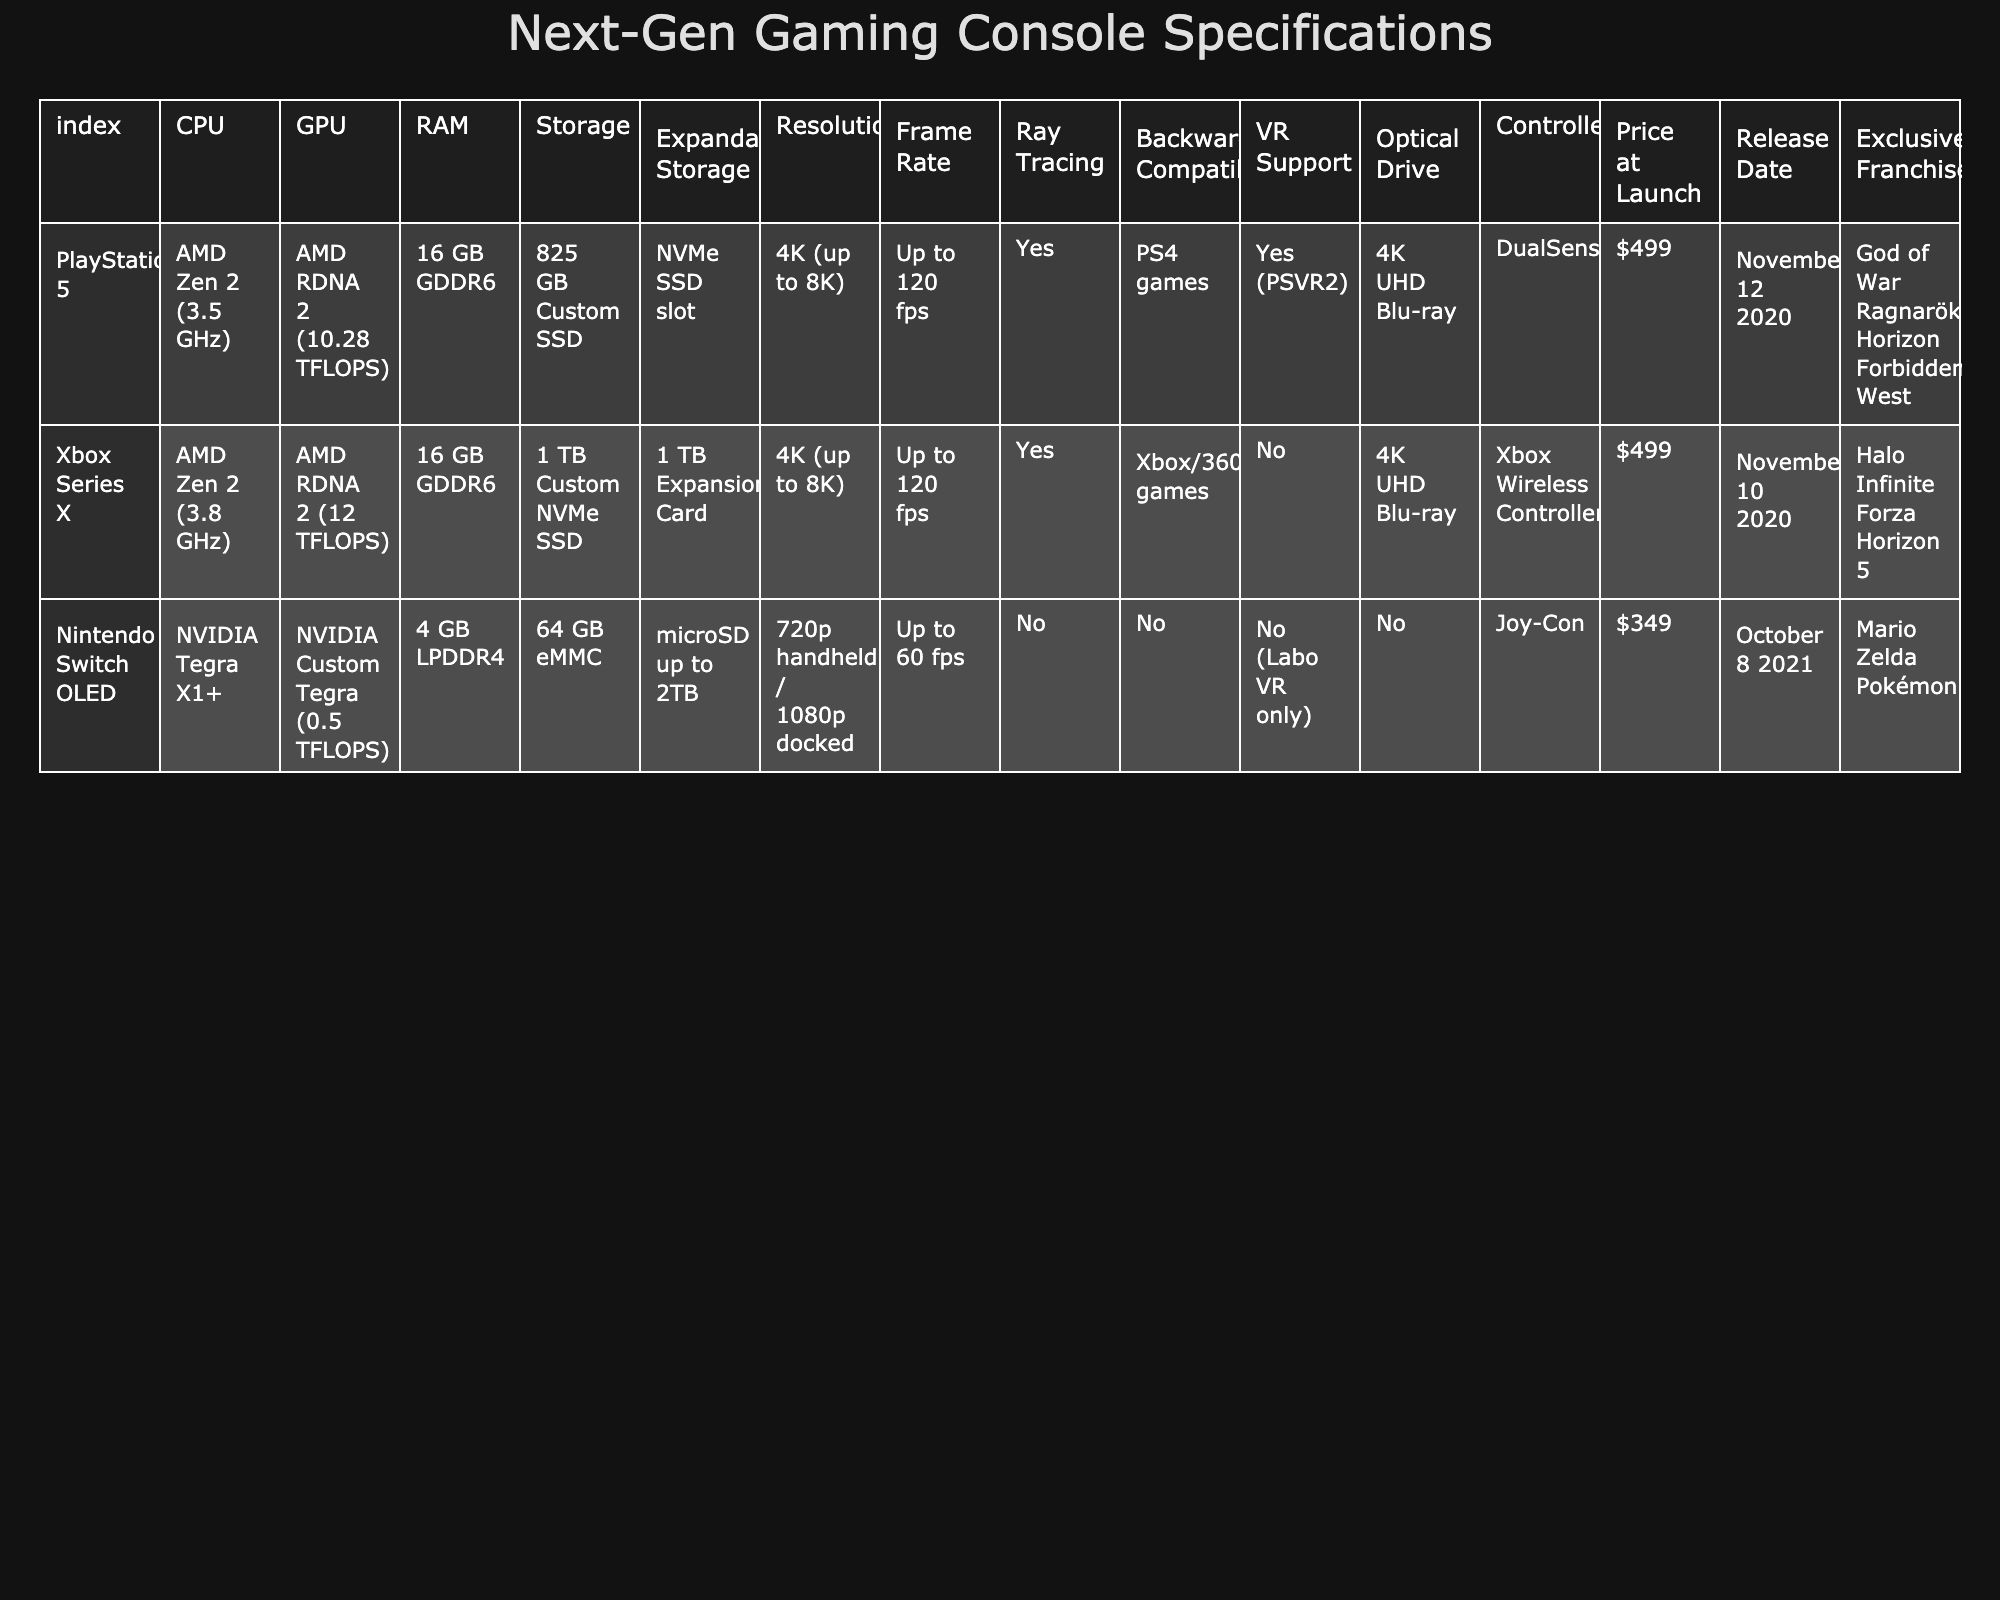What is the CPU model of the Xbox Series X? The Xbox Series X is listed under the "CPU" row of the table. Its CPU is specified as "AMD Zen 2 (3.8 GHz)."
Answer: AMD Zen 2 (3.8 GHz) Which console has the lowest RAM? By looking at the "RAM" column, we find that the Nintendo Switch OLED has 4 GB LPDDR4 RAM, which is less than the 16 GB GDDR6 RAM of both PlayStation 5 and Xbox Series X.
Answer: Nintendo Switch OLED Is PSVR2 supported on the Xbox Series X? The "VR Support" row shows that the Xbox Series X does not have VR support (it says "No"), while PSVR2 is specifically mentioned under the PlayStation 5.
Answer: No What is the difference in GPU performance between the Xbox Series X and the Nintendo Switch OLED? The GPU value for the Xbox Series X is 12 TFLOPS, while for the Nintendo Switch OLED it is 0.5 TFLOPS. The difference can be calculated as 12 - 0.5 = 11.5 TFLOPS.
Answer: 11.5 TFLOPS Which console has exclusive franchises featuring "God of War Ragnarök"? The "Exclusive Franchises" row lists "God of War Ragnarök" under PlayStation 5. Therefore, this console has the specified exclusive franchise.
Answer: PlayStation 5 Are all consoles capable of 4K resolution? Both the PlayStation 5 and Xbox Series X support up to 4K resolution, but the Nintendo Switch OLED only supports up to 1080p when docked; hence, all consoles are not capable of 4K.
Answer: No What is the total number of exclusive franchises for the PlayStation 5 and Nintendo Switch OLED combined? The exclusive franchises for PlayStation 5 are 2 (God of War Ragnarök, Horizon Forbidden West), while for Nintendo Switch OLED it is 3 (Mario, Zelda, Pokémon). Therefore, the total is 2 + 3 = 5.
Answer: 5 Which console has the highest expansion storage capability? The "Expandable Storage" row shows that the Nintendo Switch OLED can support microSD cards up to 2TB, while the others have lower capacities. Therefore, it has the highest capability.
Answer: Nintendo Switch OLED What is the price difference between the Xbox Series X and the Nintendo Switch OLED at launch? The launch prices are $499 for Xbox Series X and $349 for Nintendo Switch OLED. The difference is calculated as 499 - 349 = 150.
Answer: $150 